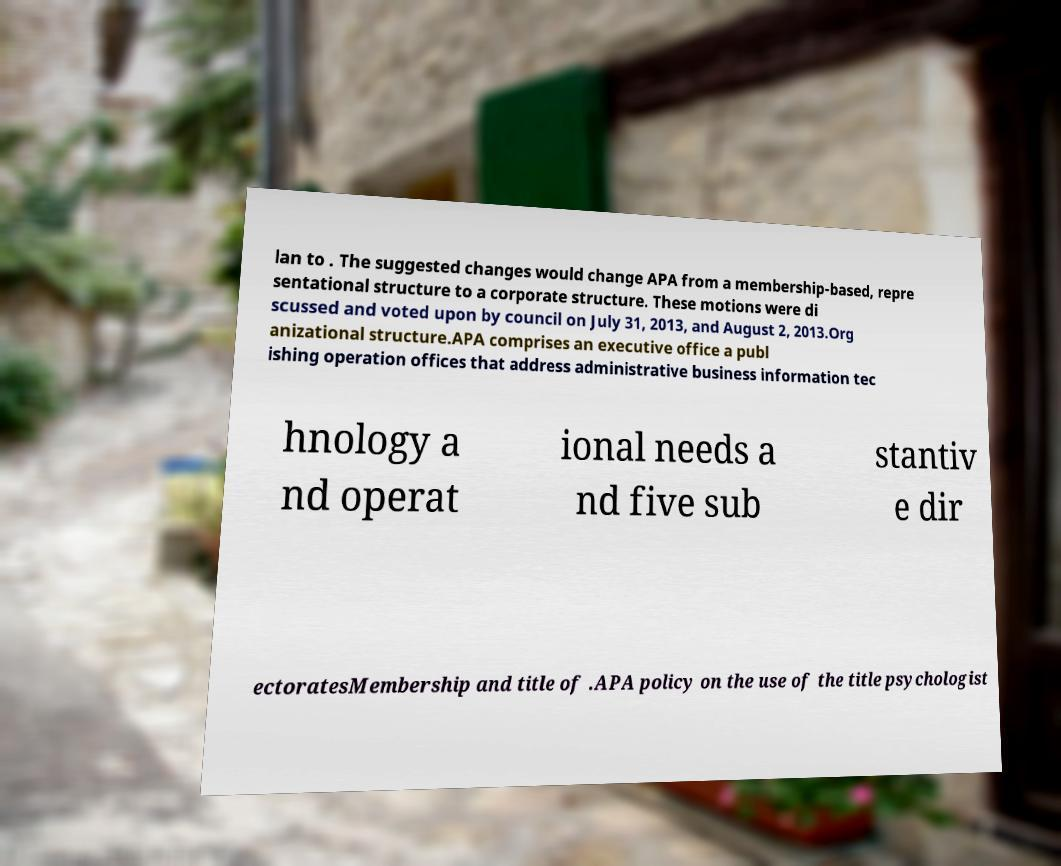Could you assist in decoding the text presented in this image and type it out clearly? lan to . The suggested changes would change APA from a membership-based, repre sentational structure to a corporate structure. These motions were di scussed and voted upon by council on July 31, 2013, and August 2, 2013.Org anizational structure.APA comprises an executive office a publ ishing operation offices that address administrative business information tec hnology a nd operat ional needs a nd five sub stantiv e dir ectoratesMembership and title of .APA policy on the use of the title psychologist 